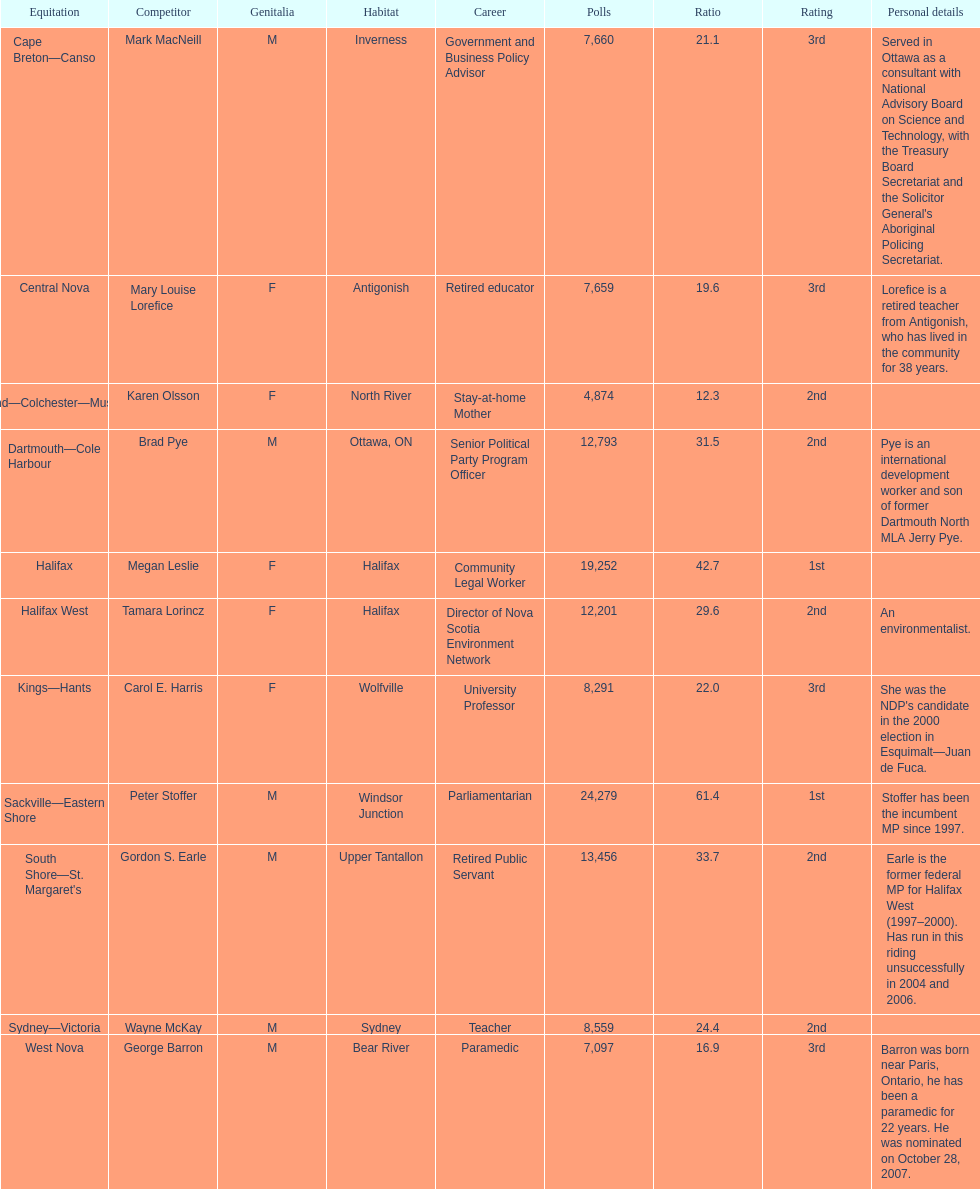How many candidates were from halifax? 2. 